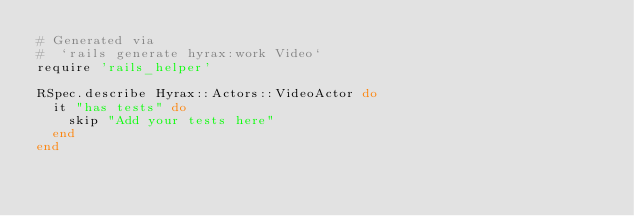<code> <loc_0><loc_0><loc_500><loc_500><_Ruby_># Generated via
#  `rails generate hyrax:work Video`
require 'rails_helper'

RSpec.describe Hyrax::Actors::VideoActor do
  it "has tests" do
    skip "Add your tests here"
  end
end
</code> 